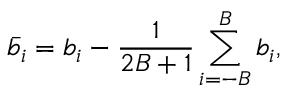Convert formula to latex. <formula><loc_0><loc_0><loc_500><loc_500>\bar { b } _ { i } = b _ { i } - \frac { 1 } { 2 B + 1 } \sum _ { i = - B } ^ { B } b _ { i } ,</formula> 